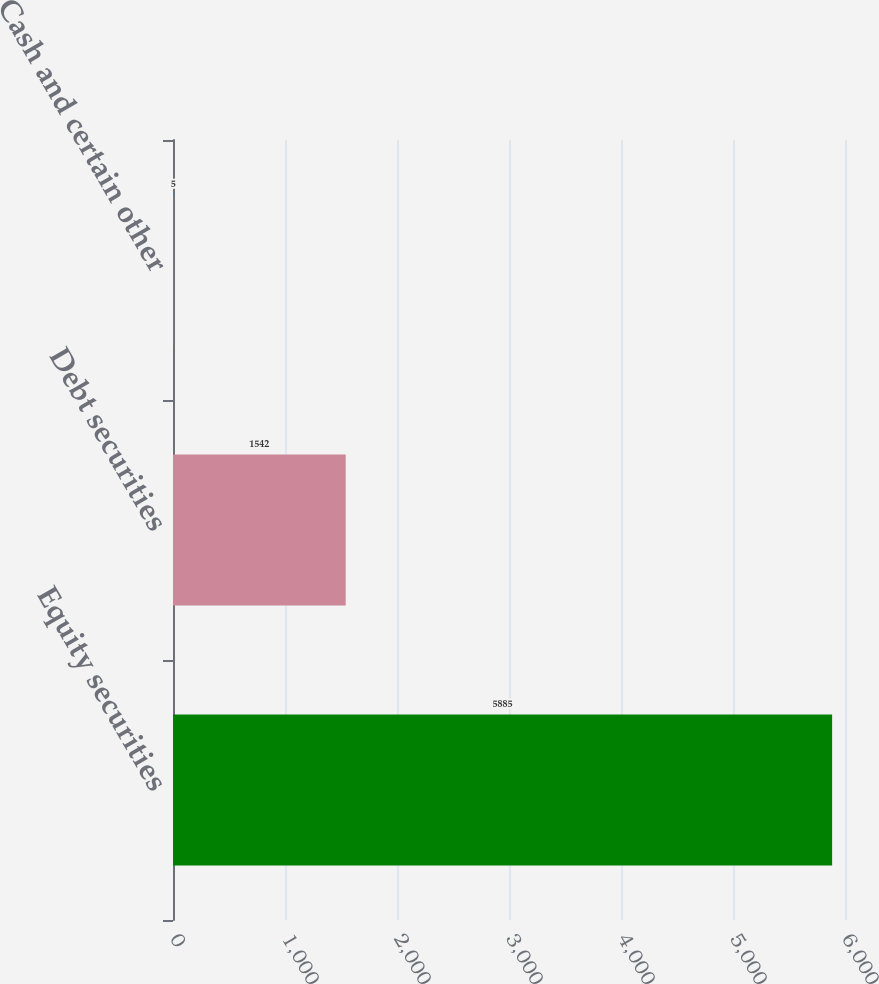<chart> <loc_0><loc_0><loc_500><loc_500><bar_chart><fcel>Equity securities<fcel>Debt securities<fcel>Cash and certain other<nl><fcel>5885<fcel>1542<fcel>5<nl></chart> 